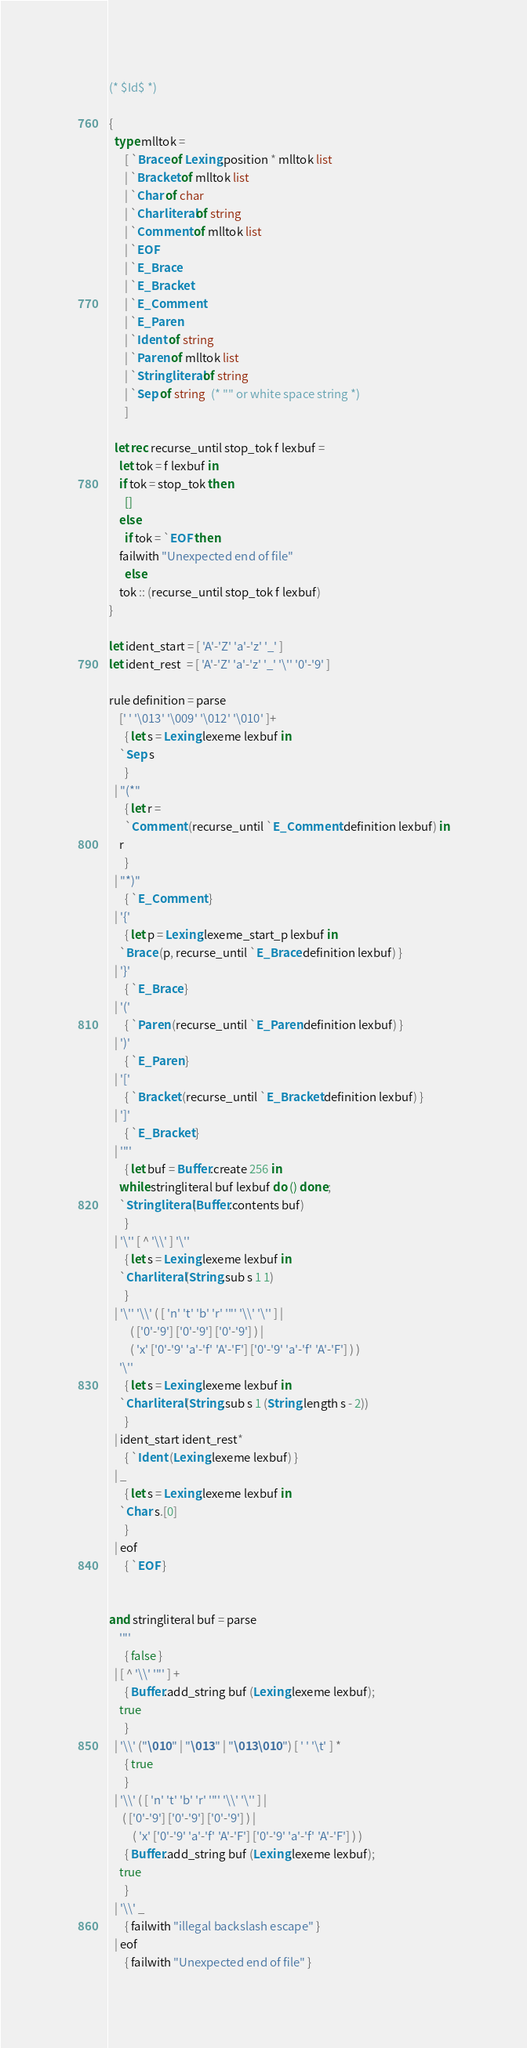<code> <loc_0><loc_0><loc_500><loc_500><_OCaml_>(* $Id$ *)

{
  type mlltok =
      [ `Brace of Lexing.position * mlltok list
      | `Bracket of mlltok list
      | `Char of char
      | `Charliteral of string
      | `Comment of mlltok list
      | `EOF
      | `E_Brace
      | `E_Bracket
      | `E_Comment
      | `E_Paren
      | `Ident of string
      | `Paren of mlltok list
      | `Stringliteral of string
      | `Sep of string  (* "" or white space string *)
      ]

  let rec recurse_until stop_tok f lexbuf =
    let tok = f lexbuf in
    if tok = stop_tok then
      []
    else
      if tok = `EOF then
	failwith "Unexpected end of file"
      else
	tok :: (recurse_until stop_tok f lexbuf)
}

let ident_start = [ 'A'-'Z' 'a'-'z' '_' ]
let ident_rest  = [ 'A'-'Z' 'a'-'z' '_' '\'' '0'-'9' ]

rule definition = parse
    [' ' '\013' '\009' '\012' '\010' ]+
      { let s = Lexing.lexeme lexbuf in
	`Sep s
      }
  | "(*"
      { let r =
	  `Comment (recurse_until `E_Comment definition lexbuf) in
	r
      }
  | "*)"
      { `E_Comment }
  | '{'
      { let p = Lexing.lexeme_start_p lexbuf in
	`Brace (p, recurse_until `E_Brace definition lexbuf) }
  | '}'
      { `E_Brace }
  | '('
      { `Paren (recurse_until `E_Paren definition lexbuf) }
  | ')'
      { `E_Paren }
  | '['
      { `Bracket (recurse_until `E_Bracket definition lexbuf) }
  | ']'
      { `E_Bracket }
  | '"'
      { let buf = Buffer.create 256 in
	while stringliteral buf lexbuf do () done;
	`Stringliteral (Buffer.contents buf)
      }
  | '\'' [ ^ '\\' ] '\''
      { let s = Lexing.lexeme lexbuf in
	`Charliteral (String.sub s 1 1)
      }
  | '\'' '\\' ( [ 'n' 't' 'b' 'r' '"' '\\' '\'' ] |
		( ['0'-'9'] ['0'-'9'] ['0'-'9'] ) |
		( 'x' ['0'-'9' 'a'-'f' 'A'-'F'] ['0'-'9' 'a'-'f' 'A'-'F'] ) )
    '\''
      { let s = Lexing.lexeme lexbuf in
	`Charliteral (String.sub s 1 (String.length s - 2))
      }
  | ident_start ident_rest*
      { `Ident (Lexing.lexeme lexbuf) }
  | _
      { let s = Lexing.lexeme lexbuf in
	`Char s.[0]
      }
  | eof
      { `EOF }


and stringliteral buf = parse
    '"'
      { false }
  | [ ^ '\\' '"' ] +
      { Buffer.add_string buf (Lexing.lexeme lexbuf);
	true
      }
  | '\\' ("\010" | "\013" | "\013\010") [ ' ' '\t' ] *
      { true
      }
  | '\\' ( [ 'n' 't' 'b' 'r' '"' '\\' '\'' ] |
	 ( ['0'-'9'] ['0'-'9'] ['0'-'9'] ) |
         ( 'x' ['0'-'9' 'a'-'f' 'A'-'F'] ['0'-'9' 'a'-'f' 'A'-'F'] ) )
      { Buffer.add_string buf (Lexing.lexeme lexbuf);
	true
      }
  | '\\' _
      { failwith "illegal backslash escape" }
  | eof
      { failwith "Unexpected end of file" }

</code> 